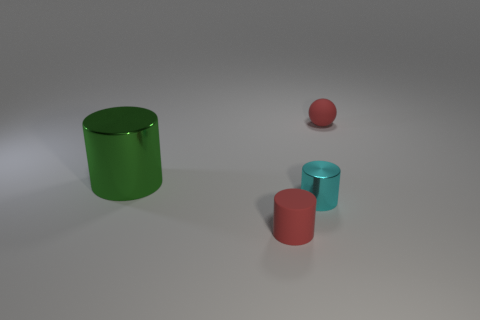Subtract all tiny cylinders. How many cylinders are left? 1 Add 4 green metal things. How many objects exist? 8 Subtract 0 blue balls. How many objects are left? 4 Subtract all balls. How many objects are left? 3 Subtract all cyan things. Subtract all small cyan cylinders. How many objects are left? 2 Add 2 tiny balls. How many tiny balls are left? 3 Add 3 large green blocks. How many large green blocks exist? 3 